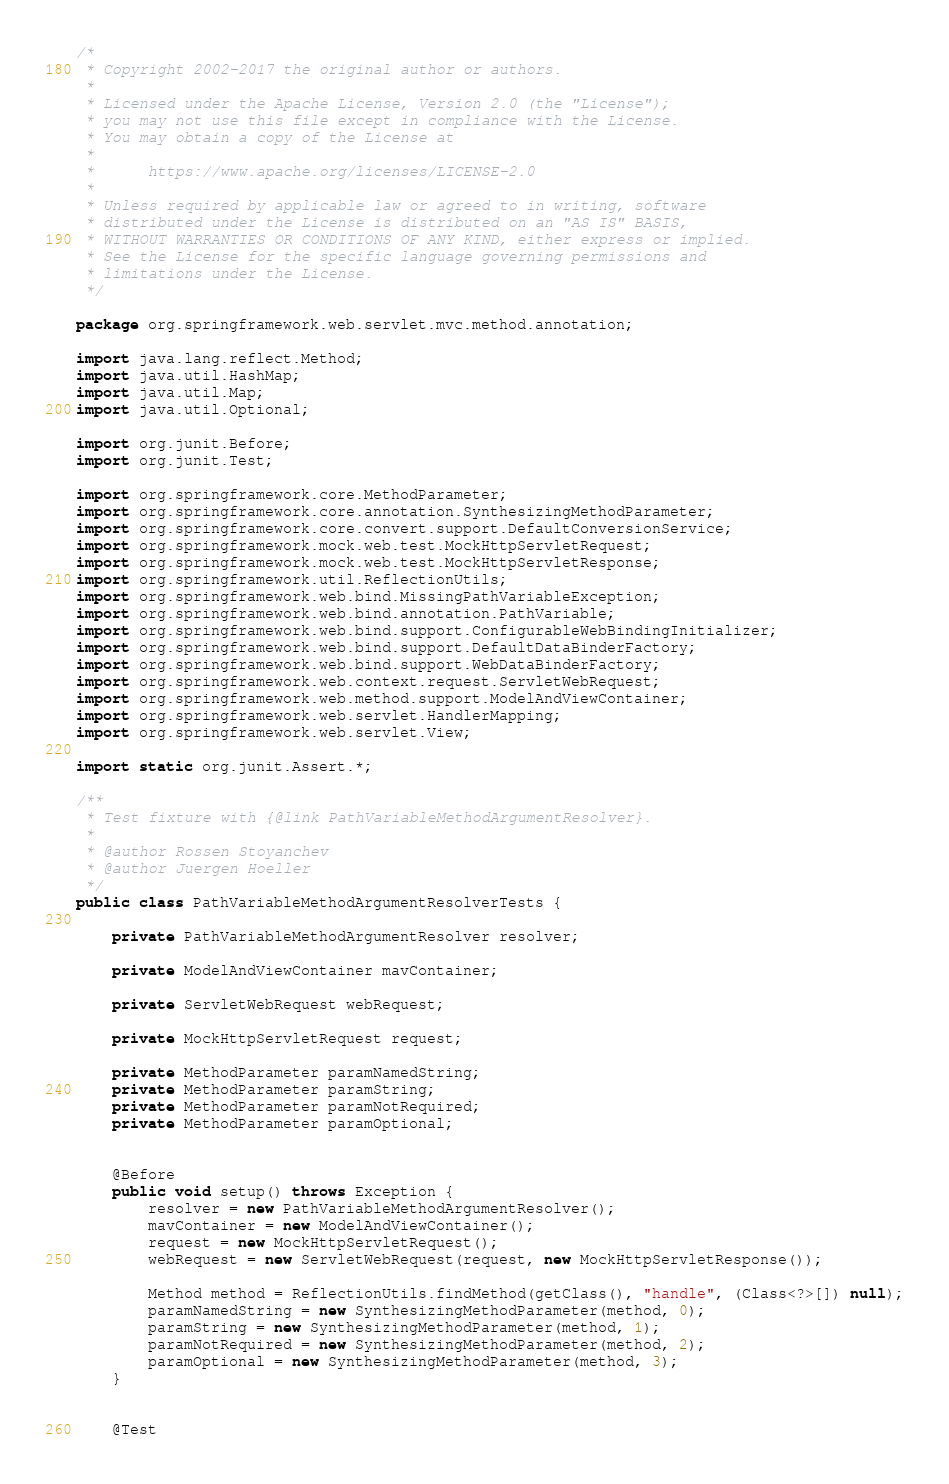<code> <loc_0><loc_0><loc_500><loc_500><_Java_>/*
 * Copyright 2002-2017 the original author or authors.
 *
 * Licensed under the Apache License, Version 2.0 (the "License");
 * you may not use this file except in compliance with the License.
 * You may obtain a copy of the License at
 *
 *      https://www.apache.org/licenses/LICENSE-2.0
 *
 * Unless required by applicable law or agreed to in writing, software
 * distributed under the License is distributed on an "AS IS" BASIS,
 * WITHOUT WARRANTIES OR CONDITIONS OF ANY KIND, either express or implied.
 * See the License for the specific language governing permissions and
 * limitations under the License.
 */

package org.springframework.web.servlet.mvc.method.annotation;

import java.lang.reflect.Method;
import java.util.HashMap;
import java.util.Map;
import java.util.Optional;

import org.junit.Before;
import org.junit.Test;

import org.springframework.core.MethodParameter;
import org.springframework.core.annotation.SynthesizingMethodParameter;
import org.springframework.core.convert.support.DefaultConversionService;
import org.springframework.mock.web.test.MockHttpServletRequest;
import org.springframework.mock.web.test.MockHttpServletResponse;
import org.springframework.util.ReflectionUtils;
import org.springframework.web.bind.MissingPathVariableException;
import org.springframework.web.bind.annotation.PathVariable;
import org.springframework.web.bind.support.ConfigurableWebBindingInitializer;
import org.springframework.web.bind.support.DefaultDataBinderFactory;
import org.springframework.web.bind.support.WebDataBinderFactory;
import org.springframework.web.context.request.ServletWebRequest;
import org.springframework.web.method.support.ModelAndViewContainer;
import org.springframework.web.servlet.HandlerMapping;
import org.springframework.web.servlet.View;

import static org.junit.Assert.*;

/**
 * Test fixture with {@link PathVariableMethodArgumentResolver}.
 *
 * @author Rossen Stoyanchev
 * @author Juergen Hoeller
 */
public class PathVariableMethodArgumentResolverTests {

	private PathVariableMethodArgumentResolver resolver;

	private ModelAndViewContainer mavContainer;

	private ServletWebRequest webRequest;

	private MockHttpServletRequest request;

	private MethodParameter paramNamedString;
	private MethodParameter paramString;
	private MethodParameter paramNotRequired;
	private MethodParameter paramOptional;


	@Before
	public void setup() throws Exception {
		resolver = new PathVariableMethodArgumentResolver();
		mavContainer = new ModelAndViewContainer();
		request = new MockHttpServletRequest();
		webRequest = new ServletWebRequest(request, new MockHttpServletResponse());

		Method method = ReflectionUtils.findMethod(getClass(), "handle", (Class<?>[]) null);
		paramNamedString = new SynthesizingMethodParameter(method, 0);
		paramString = new SynthesizingMethodParameter(method, 1);
		paramNotRequired = new SynthesizingMethodParameter(method, 2);
		paramOptional = new SynthesizingMethodParameter(method, 3);
	}


	@Test</code> 